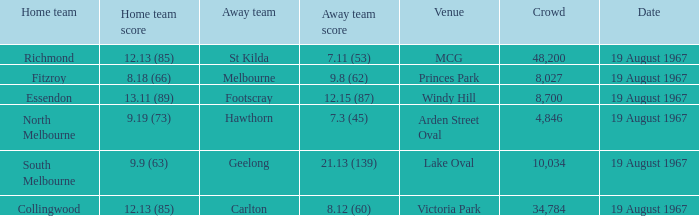If the away team scored 7.3 (45), what was the home team score? 9.19 (73). 